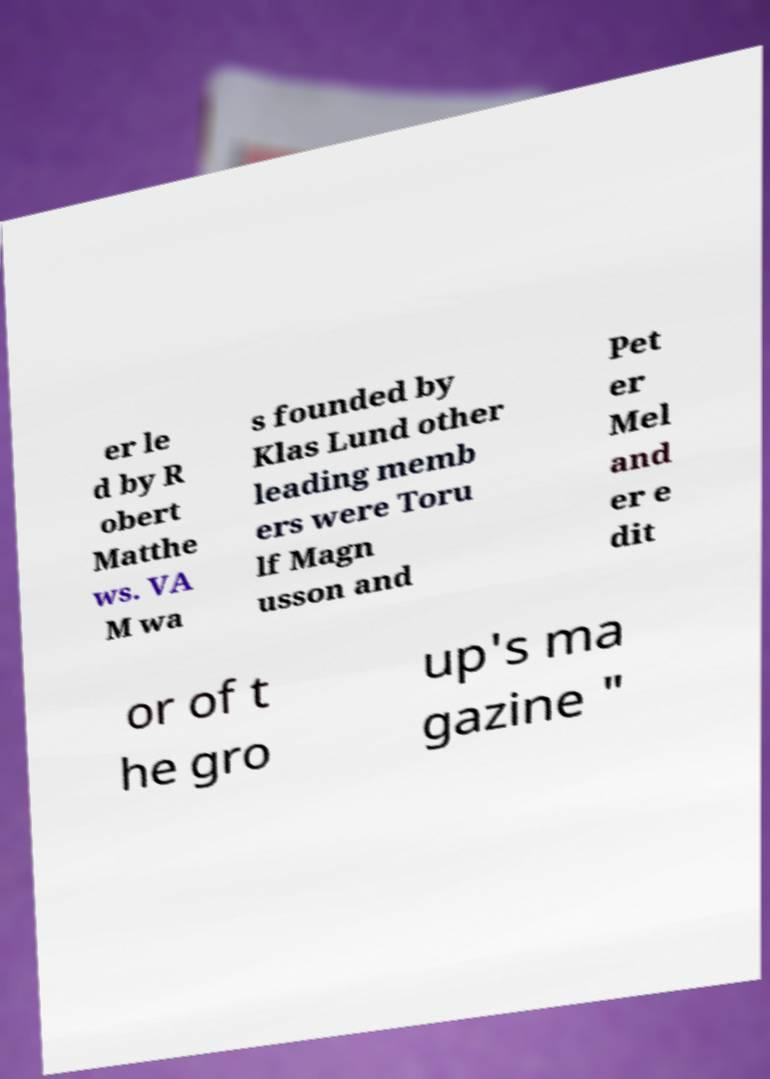I need the written content from this picture converted into text. Can you do that? er le d by R obert Matthe ws. VA M wa s founded by Klas Lund other leading memb ers were Toru lf Magn usson and Pet er Mel and er e dit or of t he gro up's ma gazine " 